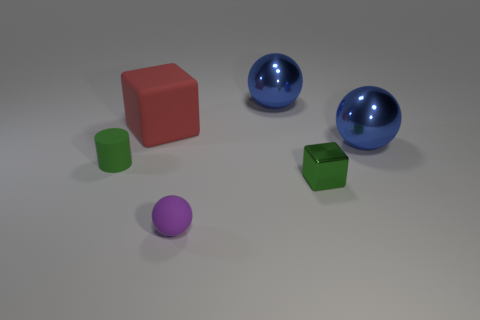Are there any other things that have the same shape as the tiny green matte object?
Provide a short and direct response. No. How many cyan blocks are there?
Give a very brief answer. 0. What number of tiny cubes are the same color as the cylinder?
Offer a terse response. 1. Do the small green metal object and the red thing have the same shape?
Keep it short and to the point. Yes. There is a ball that is on the left side of the large ball that is left of the green metallic thing; how big is it?
Your answer should be very brief. Small. Are there any blocks that have the same size as the red object?
Provide a short and direct response. No. Does the blue thing on the right side of the green block have the same size as the cube behind the small green cube?
Ensure brevity in your answer.  Yes. There is a green thing to the left of the block that is in front of the large matte cube; what is its shape?
Provide a short and direct response. Cylinder. How many large balls are in front of the large red matte object?
Your answer should be compact. 1. The ball that is made of the same material as the big red block is what color?
Give a very brief answer. Purple. 